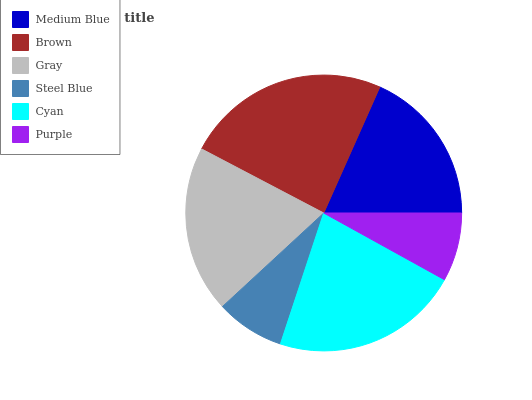Is Purple the minimum?
Answer yes or no. Yes. Is Brown the maximum?
Answer yes or no. Yes. Is Gray the minimum?
Answer yes or no. No. Is Gray the maximum?
Answer yes or no. No. Is Brown greater than Gray?
Answer yes or no. Yes. Is Gray less than Brown?
Answer yes or no. Yes. Is Gray greater than Brown?
Answer yes or no. No. Is Brown less than Gray?
Answer yes or no. No. Is Gray the high median?
Answer yes or no. Yes. Is Medium Blue the low median?
Answer yes or no. Yes. Is Cyan the high median?
Answer yes or no. No. Is Purple the low median?
Answer yes or no. No. 